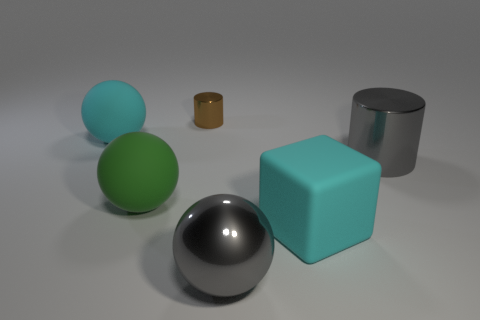Add 1 blue spheres. How many objects exist? 7 Subtract all brown cylinders. How many cylinders are left? 1 Subtract 1 blocks. How many blocks are left? 0 Subtract all yellow blocks. Subtract all brown spheres. How many blocks are left? 1 Subtract all purple blocks. How many cyan balls are left? 1 Subtract all large purple things. Subtract all rubber spheres. How many objects are left? 4 Add 1 big cyan spheres. How many big cyan spheres are left? 2 Add 4 purple matte objects. How many purple matte objects exist? 4 Subtract all gray balls. How many balls are left? 2 Subtract 0 brown cubes. How many objects are left? 6 